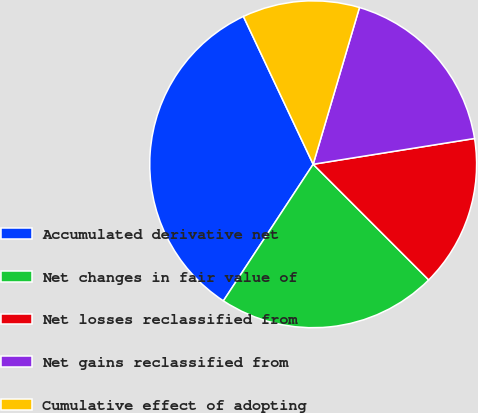Convert chart. <chart><loc_0><loc_0><loc_500><loc_500><pie_chart><fcel>Accumulated derivative net<fcel>Net changes in fair value of<fcel>Net losses reclassified from<fcel>Net gains reclassified from<fcel>Cumulative effect of adopting<nl><fcel>33.73%<fcel>21.75%<fcel>15.03%<fcel>17.91%<fcel>11.59%<nl></chart> 